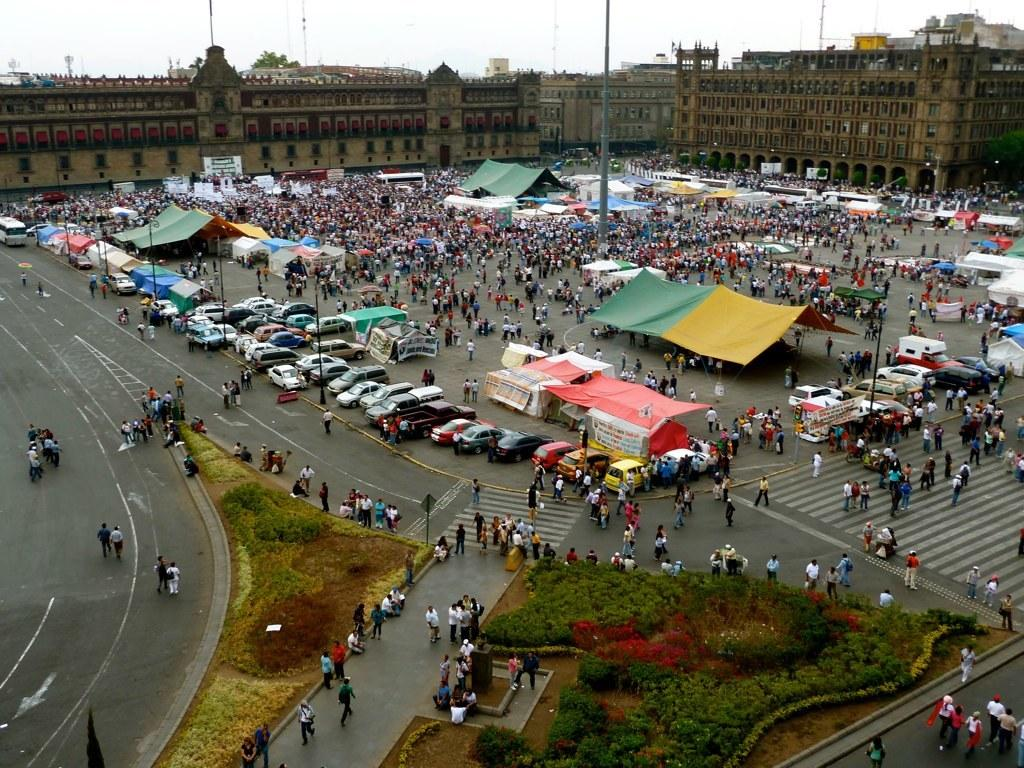How many people are in the group visible in the image? There is a group of people in the image, but the exact number is not specified. What type of infrastructure can be seen in the image? There are roads, vehicles, tents, poles, buildings, and banners visible in the image. What type of natural elements are present in the image? There are plants, trees, and the sky visible in the image. What is the background of the image? The sky is visible in the background of the image. Can you see a ladybug crawling on the banner in the image? There is no ladybug present in the image. What phase is the moon in the image? There is no moon visible in the image. 